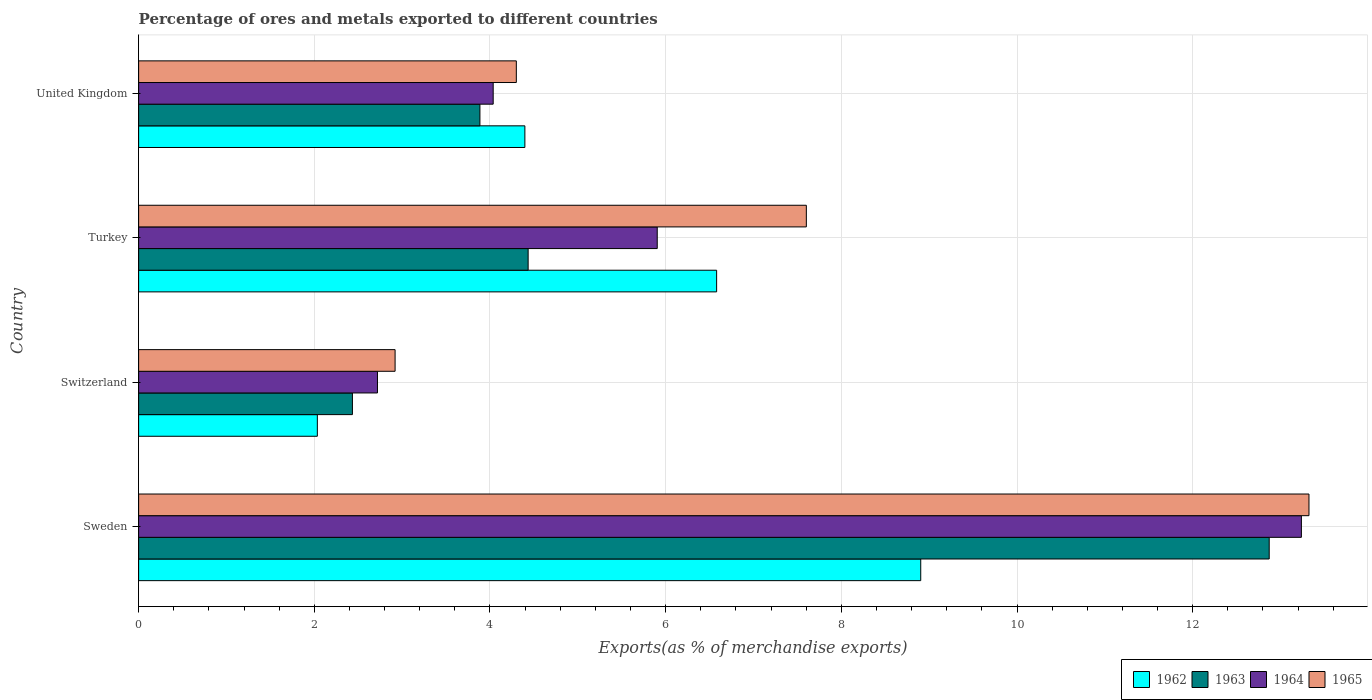How many groups of bars are there?
Provide a succinct answer. 4. How many bars are there on the 3rd tick from the bottom?
Make the answer very short. 4. What is the label of the 1st group of bars from the top?
Your answer should be compact. United Kingdom. What is the percentage of exports to different countries in 1965 in United Kingdom?
Give a very brief answer. 4.3. Across all countries, what is the maximum percentage of exports to different countries in 1962?
Give a very brief answer. 8.9. Across all countries, what is the minimum percentage of exports to different countries in 1964?
Your answer should be compact. 2.72. In which country was the percentage of exports to different countries in 1965 maximum?
Make the answer very short. Sweden. In which country was the percentage of exports to different countries in 1963 minimum?
Provide a succinct answer. Switzerland. What is the total percentage of exports to different countries in 1964 in the graph?
Offer a terse response. 25.9. What is the difference between the percentage of exports to different countries in 1962 in Turkey and that in United Kingdom?
Provide a succinct answer. 2.18. What is the difference between the percentage of exports to different countries in 1963 in Switzerland and the percentage of exports to different countries in 1962 in Sweden?
Ensure brevity in your answer.  -6.47. What is the average percentage of exports to different countries in 1962 per country?
Offer a terse response. 5.48. What is the difference between the percentage of exports to different countries in 1964 and percentage of exports to different countries in 1962 in Turkey?
Provide a short and direct response. -0.68. In how many countries, is the percentage of exports to different countries in 1964 greater than 12.4 %?
Make the answer very short. 1. What is the ratio of the percentage of exports to different countries in 1965 in Switzerland to that in Turkey?
Provide a succinct answer. 0.38. What is the difference between the highest and the second highest percentage of exports to different countries in 1965?
Keep it short and to the point. 5.72. What is the difference between the highest and the lowest percentage of exports to different countries in 1964?
Give a very brief answer. 10.52. In how many countries, is the percentage of exports to different countries in 1965 greater than the average percentage of exports to different countries in 1965 taken over all countries?
Your answer should be very brief. 2. Is the sum of the percentage of exports to different countries in 1964 in Switzerland and Turkey greater than the maximum percentage of exports to different countries in 1965 across all countries?
Make the answer very short. No. Is it the case that in every country, the sum of the percentage of exports to different countries in 1964 and percentage of exports to different countries in 1965 is greater than the sum of percentage of exports to different countries in 1963 and percentage of exports to different countries in 1962?
Give a very brief answer. No. How many bars are there?
Give a very brief answer. 16. How many countries are there in the graph?
Provide a short and direct response. 4. What is the difference between two consecutive major ticks on the X-axis?
Provide a succinct answer. 2. Does the graph contain grids?
Give a very brief answer. Yes. How many legend labels are there?
Provide a succinct answer. 4. How are the legend labels stacked?
Make the answer very short. Horizontal. What is the title of the graph?
Give a very brief answer. Percentage of ores and metals exported to different countries. Does "1965" appear as one of the legend labels in the graph?
Provide a succinct answer. Yes. What is the label or title of the X-axis?
Give a very brief answer. Exports(as % of merchandise exports). What is the label or title of the Y-axis?
Give a very brief answer. Country. What is the Exports(as % of merchandise exports) in 1962 in Sweden?
Your answer should be compact. 8.9. What is the Exports(as % of merchandise exports) in 1963 in Sweden?
Your answer should be compact. 12.87. What is the Exports(as % of merchandise exports) in 1964 in Sweden?
Offer a terse response. 13.24. What is the Exports(as % of merchandise exports) of 1965 in Sweden?
Your answer should be very brief. 13.32. What is the Exports(as % of merchandise exports) of 1962 in Switzerland?
Give a very brief answer. 2.03. What is the Exports(as % of merchandise exports) in 1963 in Switzerland?
Your response must be concise. 2.43. What is the Exports(as % of merchandise exports) in 1964 in Switzerland?
Offer a very short reply. 2.72. What is the Exports(as % of merchandise exports) of 1965 in Switzerland?
Your answer should be compact. 2.92. What is the Exports(as % of merchandise exports) of 1962 in Turkey?
Your response must be concise. 6.58. What is the Exports(as % of merchandise exports) in 1963 in Turkey?
Ensure brevity in your answer.  4.43. What is the Exports(as % of merchandise exports) in 1964 in Turkey?
Offer a terse response. 5.9. What is the Exports(as % of merchandise exports) in 1965 in Turkey?
Provide a short and direct response. 7.6. What is the Exports(as % of merchandise exports) in 1962 in United Kingdom?
Your answer should be very brief. 4.4. What is the Exports(as % of merchandise exports) of 1963 in United Kingdom?
Keep it short and to the point. 3.89. What is the Exports(as % of merchandise exports) in 1964 in United Kingdom?
Keep it short and to the point. 4.04. What is the Exports(as % of merchandise exports) of 1965 in United Kingdom?
Keep it short and to the point. 4.3. Across all countries, what is the maximum Exports(as % of merchandise exports) of 1962?
Make the answer very short. 8.9. Across all countries, what is the maximum Exports(as % of merchandise exports) in 1963?
Provide a succinct answer. 12.87. Across all countries, what is the maximum Exports(as % of merchandise exports) of 1964?
Provide a succinct answer. 13.24. Across all countries, what is the maximum Exports(as % of merchandise exports) in 1965?
Ensure brevity in your answer.  13.32. Across all countries, what is the minimum Exports(as % of merchandise exports) of 1962?
Offer a very short reply. 2.03. Across all countries, what is the minimum Exports(as % of merchandise exports) in 1963?
Offer a very short reply. 2.43. Across all countries, what is the minimum Exports(as % of merchandise exports) of 1964?
Make the answer very short. 2.72. Across all countries, what is the minimum Exports(as % of merchandise exports) in 1965?
Your response must be concise. 2.92. What is the total Exports(as % of merchandise exports) of 1962 in the graph?
Make the answer very short. 21.92. What is the total Exports(as % of merchandise exports) in 1963 in the graph?
Ensure brevity in your answer.  23.63. What is the total Exports(as % of merchandise exports) of 1964 in the graph?
Your answer should be compact. 25.9. What is the total Exports(as % of merchandise exports) in 1965 in the graph?
Give a very brief answer. 28.15. What is the difference between the Exports(as % of merchandise exports) in 1962 in Sweden and that in Switzerland?
Make the answer very short. 6.87. What is the difference between the Exports(as % of merchandise exports) of 1963 in Sweden and that in Switzerland?
Ensure brevity in your answer.  10.44. What is the difference between the Exports(as % of merchandise exports) in 1964 in Sweden and that in Switzerland?
Keep it short and to the point. 10.52. What is the difference between the Exports(as % of merchandise exports) in 1965 in Sweden and that in Switzerland?
Keep it short and to the point. 10.4. What is the difference between the Exports(as % of merchandise exports) in 1962 in Sweden and that in Turkey?
Provide a short and direct response. 2.32. What is the difference between the Exports(as % of merchandise exports) in 1963 in Sweden and that in Turkey?
Provide a short and direct response. 8.44. What is the difference between the Exports(as % of merchandise exports) of 1964 in Sweden and that in Turkey?
Your answer should be very brief. 7.33. What is the difference between the Exports(as % of merchandise exports) in 1965 in Sweden and that in Turkey?
Your response must be concise. 5.72. What is the difference between the Exports(as % of merchandise exports) of 1962 in Sweden and that in United Kingdom?
Provide a succinct answer. 4.51. What is the difference between the Exports(as % of merchandise exports) in 1963 in Sweden and that in United Kingdom?
Provide a succinct answer. 8.99. What is the difference between the Exports(as % of merchandise exports) of 1964 in Sweden and that in United Kingdom?
Give a very brief answer. 9.2. What is the difference between the Exports(as % of merchandise exports) of 1965 in Sweden and that in United Kingdom?
Your response must be concise. 9.02. What is the difference between the Exports(as % of merchandise exports) of 1962 in Switzerland and that in Turkey?
Provide a short and direct response. -4.55. What is the difference between the Exports(as % of merchandise exports) of 1963 in Switzerland and that in Turkey?
Your answer should be very brief. -2. What is the difference between the Exports(as % of merchandise exports) of 1964 in Switzerland and that in Turkey?
Offer a very short reply. -3.19. What is the difference between the Exports(as % of merchandise exports) in 1965 in Switzerland and that in Turkey?
Give a very brief answer. -4.68. What is the difference between the Exports(as % of merchandise exports) in 1962 in Switzerland and that in United Kingdom?
Ensure brevity in your answer.  -2.36. What is the difference between the Exports(as % of merchandise exports) of 1963 in Switzerland and that in United Kingdom?
Provide a succinct answer. -1.45. What is the difference between the Exports(as % of merchandise exports) in 1964 in Switzerland and that in United Kingdom?
Provide a succinct answer. -1.32. What is the difference between the Exports(as % of merchandise exports) in 1965 in Switzerland and that in United Kingdom?
Provide a short and direct response. -1.38. What is the difference between the Exports(as % of merchandise exports) in 1962 in Turkey and that in United Kingdom?
Your answer should be compact. 2.18. What is the difference between the Exports(as % of merchandise exports) in 1963 in Turkey and that in United Kingdom?
Offer a terse response. 0.55. What is the difference between the Exports(as % of merchandise exports) of 1964 in Turkey and that in United Kingdom?
Give a very brief answer. 1.87. What is the difference between the Exports(as % of merchandise exports) of 1965 in Turkey and that in United Kingdom?
Your answer should be very brief. 3.3. What is the difference between the Exports(as % of merchandise exports) of 1962 in Sweden and the Exports(as % of merchandise exports) of 1963 in Switzerland?
Provide a succinct answer. 6.47. What is the difference between the Exports(as % of merchandise exports) in 1962 in Sweden and the Exports(as % of merchandise exports) in 1964 in Switzerland?
Provide a short and direct response. 6.18. What is the difference between the Exports(as % of merchandise exports) of 1962 in Sweden and the Exports(as % of merchandise exports) of 1965 in Switzerland?
Keep it short and to the point. 5.98. What is the difference between the Exports(as % of merchandise exports) in 1963 in Sweden and the Exports(as % of merchandise exports) in 1964 in Switzerland?
Give a very brief answer. 10.15. What is the difference between the Exports(as % of merchandise exports) of 1963 in Sweden and the Exports(as % of merchandise exports) of 1965 in Switzerland?
Give a very brief answer. 9.95. What is the difference between the Exports(as % of merchandise exports) in 1964 in Sweden and the Exports(as % of merchandise exports) in 1965 in Switzerland?
Your answer should be very brief. 10.32. What is the difference between the Exports(as % of merchandise exports) in 1962 in Sweden and the Exports(as % of merchandise exports) in 1963 in Turkey?
Provide a succinct answer. 4.47. What is the difference between the Exports(as % of merchandise exports) of 1962 in Sweden and the Exports(as % of merchandise exports) of 1964 in Turkey?
Your response must be concise. 3. What is the difference between the Exports(as % of merchandise exports) of 1962 in Sweden and the Exports(as % of merchandise exports) of 1965 in Turkey?
Keep it short and to the point. 1.3. What is the difference between the Exports(as % of merchandise exports) in 1963 in Sweden and the Exports(as % of merchandise exports) in 1964 in Turkey?
Your response must be concise. 6.97. What is the difference between the Exports(as % of merchandise exports) of 1963 in Sweden and the Exports(as % of merchandise exports) of 1965 in Turkey?
Make the answer very short. 5.27. What is the difference between the Exports(as % of merchandise exports) in 1964 in Sweden and the Exports(as % of merchandise exports) in 1965 in Turkey?
Provide a succinct answer. 5.64. What is the difference between the Exports(as % of merchandise exports) in 1962 in Sweden and the Exports(as % of merchandise exports) in 1963 in United Kingdom?
Offer a terse response. 5.02. What is the difference between the Exports(as % of merchandise exports) of 1962 in Sweden and the Exports(as % of merchandise exports) of 1964 in United Kingdom?
Your answer should be compact. 4.87. What is the difference between the Exports(as % of merchandise exports) in 1962 in Sweden and the Exports(as % of merchandise exports) in 1965 in United Kingdom?
Give a very brief answer. 4.6. What is the difference between the Exports(as % of merchandise exports) in 1963 in Sweden and the Exports(as % of merchandise exports) in 1964 in United Kingdom?
Provide a short and direct response. 8.83. What is the difference between the Exports(as % of merchandise exports) in 1963 in Sweden and the Exports(as % of merchandise exports) in 1965 in United Kingdom?
Provide a succinct answer. 8.57. What is the difference between the Exports(as % of merchandise exports) in 1964 in Sweden and the Exports(as % of merchandise exports) in 1965 in United Kingdom?
Offer a terse response. 8.94. What is the difference between the Exports(as % of merchandise exports) of 1962 in Switzerland and the Exports(as % of merchandise exports) of 1963 in Turkey?
Offer a terse response. -2.4. What is the difference between the Exports(as % of merchandise exports) of 1962 in Switzerland and the Exports(as % of merchandise exports) of 1964 in Turkey?
Provide a succinct answer. -3.87. What is the difference between the Exports(as % of merchandise exports) of 1962 in Switzerland and the Exports(as % of merchandise exports) of 1965 in Turkey?
Offer a very short reply. -5.57. What is the difference between the Exports(as % of merchandise exports) of 1963 in Switzerland and the Exports(as % of merchandise exports) of 1964 in Turkey?
Give a very brief answer. -3.47. What is the difference between the Exports(as % of merchandise exports) in 1963 in Switzerland and the Exports(as % of merchandise exports) in 1965 in Turkey?
Ensure brevity in your answer.  -5.17. What is the difference between the Exports(as % of merchandise exports) in 1964 in Switzerland and the Exports(as % of merchandise exports) in 1965 in Turkey?
Give a very brief answer. -4.88. What is the difference between the Exports(as % of merchandise exports) in 1962 in Switzerland and the Exports(as % of merchandise exports) in 1963 in United Kingdom?
Ensure brevity in your answer.  -1.85. What is the difference between the Exports(as % of merchandise exports) in 1962 in Switzerland and the Exports(as % of merchandise exports) in 1964 in United Kingdom?
Give a very brief answer. -2. What is the difference between the Exports(as % of merchandise exports) in 1962 in Switzerland and the Exports(as % of merchandise exports) in 1965 in United Kingdom?
Your answer should be compact. -2.27. What is the difference between the Exports(as % of merchandise exports) in 1963 in Switzerland and the Exports(as % of merchandise exports) in 1964 in United Kingdom?
Make the answer very short. -1.6. What is the difference between the Exports(as % of merchandise exports) of 1963 in Switzerland and the Exports(as % of merchandise exports) of 1965 in United Kingdom?
Ensure brevity in your answer.  -1.87. What is the difference between the Exports(as % of merchandise exports) of 1964 in Switzerland and the Exports(as % of merchandise exports) of 1965 in United Kingdom?
Your response must be concise. -1.58. What is the difference between the Exports(as % of merchandise exports) in 1962 in Turkey and the Exports(as % of merchandise exports) in 1963 in United Kingdom?
Your response must be concise. 2.69. What is the difference between the Exports(as % of merchandise exports) in 1962 in Turkey and the Exports(as % of merchandise exports) in 1964 in United Kingdom?
Provide a succinct answer. 2.54. What is the difference between the Exports(as % of merchandise exports) in 1962 in Turkey and the Exports(as % of merchandise exports) in 1965 in United Kingdom?
Give a very brief answer. 2.28. What is the difference between the Exports(as % of merchandise exports) in 1963 in Turkey and the Exports(as % of merchandise exports) in 1964 in United Kingdom?
Provide a short and direct response. 0.4. What is the difference between the Exports(as % of merchandise exports) in 1963 in Turkey and the Exports(as % of merchandise exports) in 1965 in United Kingdom?
Make the answer very short. 0.13. What is the difference between the Exports(as % of merchandise exports) in 1964 in Turkey and the Exports(as % of merchandise exports) in 1965 in United Kingdom?
Your response must be concise. 1.6. What is the average Exports(as % of merchandise exports) in 1962 per country?
Offer a terse response. 5.48. What is the average Exports(as % of merchandise exports) of 1963 per country?
Your response must be concise. 5.91. What is the average Exports(as % of merchandise exports) in 1964 per country?
Make the answer very short. 6.47. What is the average Exports(as % of merchandise exports) of 1965 per country?
Keep it short and to the point. 7.04. What is the difference between the Exports(as % of merchandise exports) of 1962 and Exports(as % of merchandise exports) of 1963 in Sweden?
Your answer should be very brief. -3.97. What is the difference between the Exports(as % of merchandise exports) of 1962 and Exports(as % of merchandise exports) of 1964 in Sweden?
Your response must be concise. -4.33. What is the difference between the Exports(as % of merchandise exports) of 1962 and Exports(as % of merchandise exports) of 1965 in Sweden?
Your answer should be very brief. -4.42. What is the difference between the Exports(as % of merchandise exports) in 1963 and Exports(as % of merchandise exports) in 1964 in Sweden?
Your answer should be compact. -0.37. What is the difference between the Exports(as % of merchandise exports) in 1963 and Exports(as % of merchandise exports) in 1965 in Sweden?
Your response must be concise. -0.45. What is the difference between the Exports(as % of merchandise exports) of 1964 and Exports(as % of merchandise exports) of 1965 in Sweden?
Offer a very short reply. -0.09. What is the difference between the Exports(as % of merchandise exports) of 1962 and Exports(as % of merchandise exports) of 1963 in Switzerland?
Offer a terse response. -0.4. What is the difference between the Exports(as % of merchandise exports) in 1962 and Exports(as % of merchandise exports) in 1964 in Switzerland?
Offer a terse response. -0.68. What is the difference between the Exports(as % of merchandise exports) in 1962 and Exports(as % of merchandise exports) in 1965 in Switzerland?
Your answer should be very brief. -0.89. What is the difference between the Exports(as % of merchandise exports) in 1963 and Exports(as % of merchandise exports) in 1964 in Switzerland?
Offer a terse response. -0.29. What is the difference between the Exports(as % of merchandise exports) of 1963 and Exports(as % of merchandise exports) of 1965 in Switzerland?
Provide a succinct answer. -0.49. What is the difference between the Exports(as % of merchandise exports) in 1964 and Exports(as % of merchandise exports) in 1965 in Switzerland?
Offer a terse response. -0.2. What is the difference between the Exports(as % of merchandise exports) of 1962 and Exports(as % of merchandise exports) of 1963 in Turkey?
Make the answer very short. 2.15. What is the difference between the Exports(as % of merchandise exports) in 1962 and Exports(as % of merchandise exports) in 1964 in Turkey?
Keep it short and to the point. 0.68. What is the difference between the Exports(as % of merchandise exports) in 1962 and Exports(as % of merchandise exports) in 1965 in Turkey?
Provide a short and direct response. -1.02. What is the difference between the Exports(as % of merchandise exports) in 1963 and Exports(as % of merchandise exports) in 1964 in Turkey?
Your answer should be compact. -1.47. What is the difference between the Exports(as % of merchandise exports) in 1963 and Exports(as % of merchandise exports) in 1965 in Turkey?
Ensure brevity in your answer.  -3.17. What is the difference between the Exports(as % of merchandise exports) in 1964 and Exports(as % of merchandise exports) in 1965 in Turkey?
Your answer should be compact. -1.7. What is the difference between the Exports(as % of merchandise exports) in 1962 and Exports(as % of merchandise exports) in 1963 in United Kingdom?
Offer a terse response. 0.51. What is the difference between the Exports(as % of merchandise exports) of 1962 and Exports(as % of merchandise exports) of 1964 in United Kingdom?
Offer a very short reply. 0.36. What is the difference between the Exports(as % of merchandise exports) of 1962 and Exports(as % of merchandise exports) of 1965 in United Kingdom?
Make the answer very short. 0.1. What is the difference between the Exports(as % of merchandise exports) in 1963 and Exports(as % of merchandise exports) in 1964 in United Kingdom?
Provide a short and direct response. -0.15. What is the difference between the Exports(as % of merchandise exports) of 1963 and Exports(as % of merchandise exports) of 1965 in United Kingdom?
Keep it short and to the point. -0.41. What is the difference between the Exports(as % of merchandise exports) in 1964 and Exports(as % of merchandise exports) in 1965 in United Kingdom?
Your answer should be very brief. -0.26. What is the ratio of the Exports(as % of merchandise exports) in 1962 in Sweden to that in Switzerland?
Provide a short and direct response. 4.38. What is the ratio of the Exports(as % of merchandise exports) in 1963 in Sweden to that in Switzerland?
Give a very brief answer. 5.29. What is the ratio of the Exports(as % of merchandise exports) of 1964 in Sweden to that in Switzerland?
Offer a terse response. 4.87. What is the ratio of the Exports(as % of merchandise exports) of 1965 in Sweden to that in Switzerland?
Offer a terse response. 4.56. What is the ratio of the Exports(as % of merchandise exports) of 1962 in Sweden to that in Turkey?
Your answer should be compact. 1.35. What is the ratio of the Exports(as % of merchandise exports) in 1963 in Sweden to that in Turkey?
Give a very brief answer. 2.9. What is the ratio of the Exports(as % of merchandise exports) in 1964 in Sweden to that in Turkey?
Provide a short and direct response. 2.24. What is the ratio of the Exports(as % of merchandise exports) in 1965 in Sweden to that in Turkey?
Provide a short and direct response. 1.75. What is the ratio of the Exports(as % of merchandise exports) of 1962 in Sweden to that in United Kingdom?
Your response must be concise. 2.02. What is the ratio of the Exports(as % of merchandise exports) of 1963 in Sweden to that in United Kingdom?
Provide a succinct answer. 3.31. What is the ratio of the Exports(as % of merchandise exports) in 1964 in Sweden to that in United Kingdom?
Offer a very short reply. 3.28. What is the ratio of the Exports(as % of merchandise exports) in 1965 in Sweden to that in United Kingdom?
Give a very brief answer. 3.1. What is the ratio of the Exports(as % of merchandise exports) in 1962 in Switzerland to that in Turkey?
Provide a succinct answer. 0.31. What is the ratio of the Exports(as % of merchandise exports) of 1963 in Switzerland to that in Turkey?
Your response must be concise. 0.55. What is the ratio of the Exports(as % of merchandise exports) in 1964 in Switzerland to that in Turkey?
Give a very brief answer. 0.46. What is the ratio of the Exports(as % of merchandise exports) of 1965 in Switzerland to that in Turkey?
Your answer should be compact. 0.38. What is the ratio of the Exports(as % of merchandise exports) in 1962 in Switzerland to that in United Kingdom?
Make the answer very short. 0.46. What is the ratio of the Exports(as % of merchandise exports) in 1963 in Switzerland to that in United Kingdom?
Give a very brief answer. 0.63. What is the ratio of the Exports(as % of merchandise exports) of 1964 in Switzerland to that in United Kingdom?
Ensure brevity in your answer.  0.67. What is the ratio of the Exports(as % of merchandise exports) in 1965 in Switzerland to that in United Kingdom?
Your answer should be compact. 0.68. What is the ratio of the Exports(as % of merchandise exports) in 1962 in Turkey to that in United Kingdom?
Provide a succinct answer. 1.5. What is the ratio of the Exports(as % of merchandise exports) of 1963 in Turkey to that in United Kingdom?
Make the answer very short. 1.14. What is the ratio of the Exports(as % of merchandise exports) of 1964 in Turkey to that in United Kingdom?
Ensure brevity in your answer.  1.46. What is the ratio of the Exports(as % of merchandise exports) in 1965 in Turkey to that in United Kingdom?
Make the answer very short. 1.77. What is the difference between the highest and the second highest Exports(as % of merchandise exports) in 1962?
Your answer should be compact. 2.32. What is the difference between the highest and the second highest Exports(as % of merchandise exports) of 1963?
Your answer should be compact. 8.44. What is the difference between the highest and the second highest Exports(as % of merchandise exports) in 1964?
Your answer should be very brief. 7.33. What is the difference between the highest and the second highest Exports(as % of merchandise exports) of 1965?
Your answer should be compact. 5.72. What is the difference between the highest and the lowest Exports(as % of merchandise exports) in 1962?
Your answer should be compact. 6.87. What is the difference between the highest and the lowest Exports(as % of merchandise exports) of 1963?
Ensure brevity in your answer.  10.44. What is the difference between the highest and the lowest Exports(as % of merchandise exports) of 1964?
Keep it short and to the point. 10.52. What is the difference between the highest and the lowest Exports(as % of merchandise exports) of 1965?
Your answer should be compact. 10.4. 